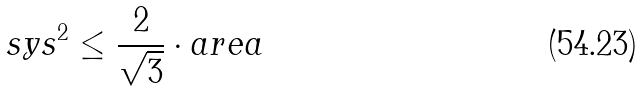Convert formula to latex. <formula><loc_0><loc_0><loc_500><loc_500>s y s ^ { 2 } \leq \frac { 2 } { \sqrt { 3 } } \cdot a r e a</formula> 